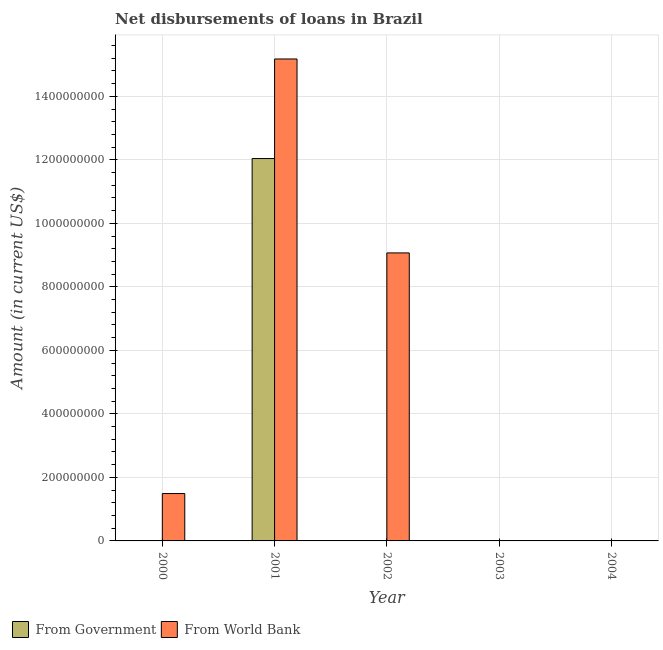Are the number of bars on each tick of the X-axis equal?
Offer a very short reply. No. How many bars are there on the 3rd tick from the right?
Give a very brief answer. 1. In how many cases, is the number of bars for a given year not equal to the number of legend labels?
Provide a succinct answer. 4. What is the net disbursements of loan from world bank in 2004?
Provide a succinct answer. 0. Across all years, what is the maximum net disbursements of loan from government?
Your answer should be very brief. 1.20e+09. What is the total net disbursements of loan from world bank in the graph?
Your answer should be very brief. 2.57e+09. What is the difference between the net disbursements of loan from world bank in 2001 and the net disbursements of loan from government in 2000?
Ensure brevity in your answer.  1.37e+09. What is the average net disbursements of loan from world bank per year?
Your response must be concise. 5.15e+08. What is the ratio of the net disbursements of loan from world bank in 2000 to that in 2002?
Give a very brief answer. 0.16. What is the difference between the highest and the second highest net disbursements of loan from world bank?
Keep it short and to the point. 6.11e+08. What is the difference between the highest and the lowest net disbursements of loan from world bank?
Your answer should be very brief. 1.52e+09. Are all the bars in the graph horizontal?
Make the answer very short. No. What is the difference between two consecutive major ticks on the Y-axis?
Provide a short and direct response. 2.00e+08. Are the values on the major ticks of Y-axis written in scientific E-notation?
Provide a short and direct response. No. Does the graph contain grids?
Keep it short and to the point. Yes. How many legend labels are there?
Keep it short and to the point. 2. What is the title of the graph?
Keep it short and to the point. Net disbursements of loans in Brazil. What is the label or title of the Y-axis?
Keep it short and to the point. Amount (in current US$). What is the Amount (in current US$) in From World Bank in 2000?
Provide a succinct answer. 1.49e+08. What is the Amount (in current US$) of From Government in 2001?
Make the answer very short. 1.20e+09. What is the Amount (in current US$) in From World Bank in 2001?
Offer a very short reply. 1.52e+09. What is the Amount (in current US$) of From World Bank in 2002?
Make the answer very short. 9.07e+08. What is the Amount (in current US$) of From World Bank in 2004?
Your answer should be very brief. 0. Across all years, what is the maximum Amount (in current US$) of From Government?
Give a very brief answer. 1.20e+09. Across all years, what is the maximum Amount (in current US$) in From World Bank?
Make the answer very short. 1.52e+09. Across all years, what is the minimum Amount (in current US$) in From Government?
Offer a terse response. 0. Across all years, what is the minimum Amount (in current US$) in From World Bank?
Make the answer very short. 0. What is the total Amount (in current US$) in From Government in the graph?
Make the answer very short. 1.20e+09. What is the total Amount (in current US$) in From World Bank in the graph?
Offer a very short reply. 2.57e+09. What is the difference between the Amount (in current US$) of From World Bank in 2000 and that in 2001?
Give a very brief answer. -1.37e+09. What is the difference between the Amount (in current US$) of From World Bank in 2000 and that in 2002?
Your response must be concise. -7.58e+08. What is the difference between the Amount (in current US$) of From World Bank in 2001 and that in 2002?
Provide a short and direct response. 6.11e+08. What is the difference between the Amount (in current US$) in From Government in 2001 and the Amount (in current US$) in From World Bank in 2002?
Ensure brevity in your answer.  2.97e+08. What is the average Amount (in current US$) of From Government per year?
Give a very brief answer. 2.41e+08. What is the average Amount (in current US$) of From World Bank per year?
Make the answer very short. 5.15e+08. In the year 2001, what is the difference between the Amount (in current US$) in From Government and Amount (in current US$) in From World Bank?
Ensure brevity in your answer.  -3.14e+08. What is the ratio of the Amount (in current US$) of From World Bank in 2000 to that in 2001?
Your answer should be compact. 0.1. What is the ratio of the Amount (in current US$) in From World Bank in 2000 to that in 2002?
Keep it short and to the point. 0.16. What is the ratio of the Amount (in current US$) in From World Bank in 2001 to that in 2002?
Make the answer very short. 1.67. What is the difference between the highest and the second highest Amount (in current US$) in From World Bank?
Provide a short and direct response. 6.11e+08. What is the difference between the highest and the lowest Amount (in current US$) of From Government?
Keep it short and to the point. 1.20e+09. What is the difference between the highest and the lowest Amount (in current US$) in From World Bank?
Your answer should be compact. 1.52e+09. 